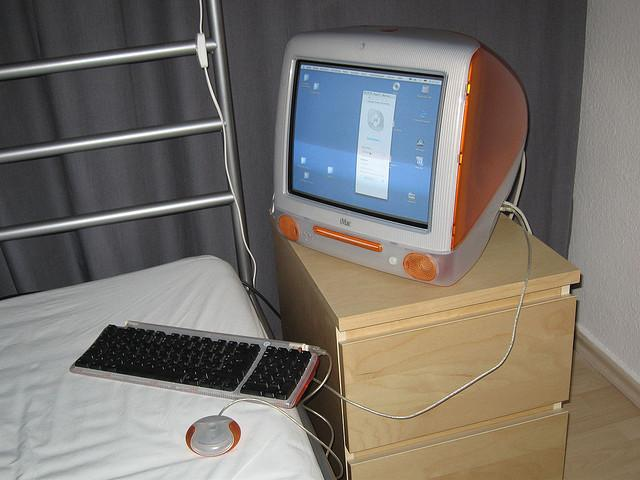What is sitting on the dresser? Please explain your reasoning. monitor. There is a large screen for a computer. 